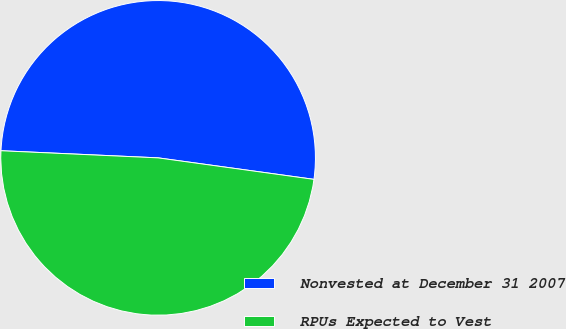<chart> <loc_0><loc_0><loc_500><loc_500><pie_chart><fcel>Nonvested at December 31 2007<fcel>RPUs Expected to Vest<nl><fcel>51.46%<fcel>48.54%<nl></chart> 